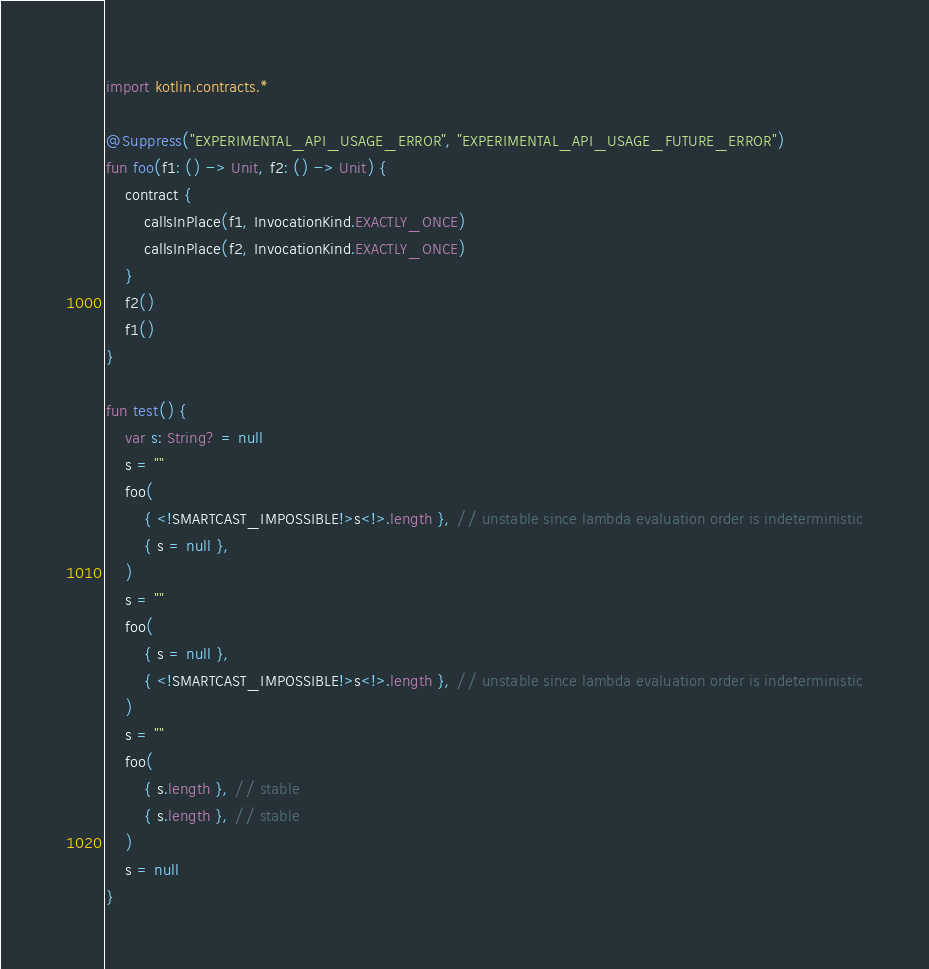<code> <loc_0><loc_0><loc_500><loc_500><_Kotlin_>import kotlin.contracts.*

@Suppress("EXPERIMENTAL_API_USAGE_ERROR", "EXPERIMENTAL_API_USAGE_FUTURE_ERROR")
fun foo(f1: () -> Unit, f2: () -> Unit) {
    contract {
        callsInPlace(f1, InvocationKind.EXACTLY_ONCE)
        callsInPlace(f2, InvocationKind.EXACTLY_ONCE)
    }
    f2()
    f1()
}

fun test() {
    var s: String? = null
    s = ""
    foo(
        { <!SMARTCAST_IMPOSSIBLE!>s<!>.length }, // unstable since lambda evaluation order is indeterministic
        { s = null },
    )
    s = ""
    foo(
        { s = null },
        { <!SMARTCAST_IMPOSSIBLE!>s<!>.length }, // unstable since lambda evaluation order is indeterministic
    )
    s = ""
    foo(
        { s.length }, // stable
        { s.length }, // stable
    )
    s = null
}
</code> 